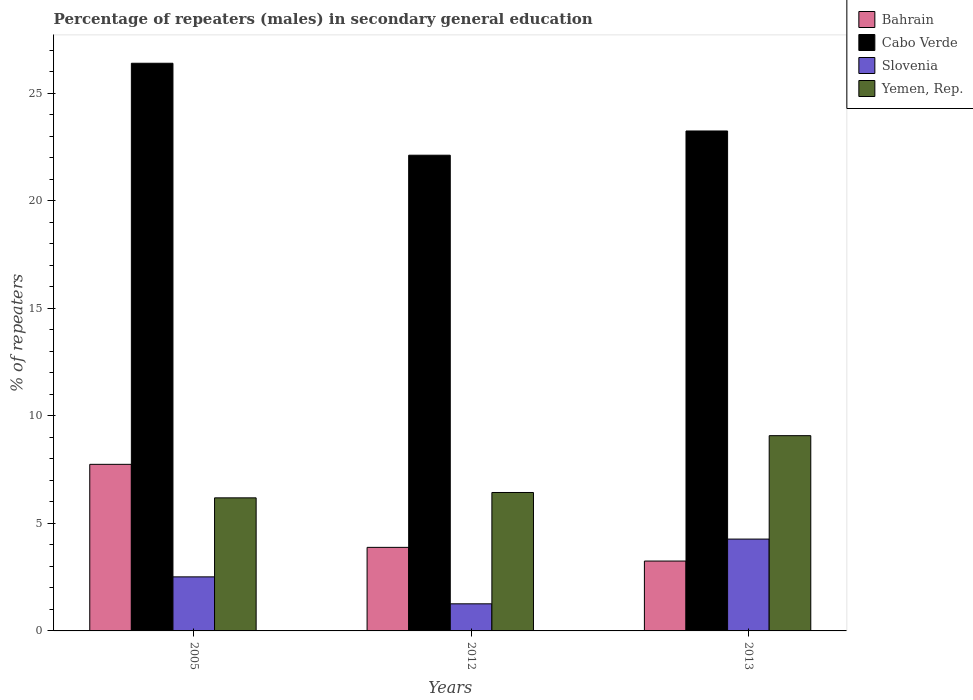How many different coloured bars are there?
Offer a very short reply. 4. How many groups of bars are there?
Your answer should be compact. 3. Are the number of bars on each tick of the X-axis equal?
Ensure brevity in your answer.  Yes. How many bars are there on the 2nd tick from the left?
Give a very brief answer. 4. How many bars are there on the 2nd tick from the right?
Your answer should be very brief. 4. What is the label of the 3rd group of bars from the left?
Ensure brevity in your answer.  2013. What is the percentage of male repeaters in Bahrain in 2005?
Provide a short and direct response. 7.74. Across all years, what is the maximum percentage of male repeaters in Bahrain?
Make the answer very short. 7.74. Across all years, what is the minimum percentage of male repeaters in Bahrain?
Your answer should be compact. 3.25. In which year was the percentage of male repeaters in Bahrain minimum?
Offer a very short reply. 2013. What is the total percentage of male repeaters in Yemen, Rep. in the graph?
Ensure brevity in your answer.  21.7. What is the difference between the percentage of male repeaters in Cabo Verde in 2012 and that in 2013?
Provide a succinct answer. -1.13. What is the difference between the percentage of male repeaters in Cabo Verde in 2005 and the percentage of male repeaters in Bahrain in 2013?
Keep it short and to the point. 23.14. What is the average percentage of male repeaters in Bahrain per year?
Your response must be concise. 4.96. In the year 2012, what is the difference between the percentage of male repeaters in Bahrain and percentage of male repeaters in Yemen, Rep.?
Provide a short and direct response. -2.55. What is the ratio of the percentage of male repeaters in Slovenia in 2005 to that in 2013?
Your answer should be compact. 0.59. What is the difference between the highest and the second highest percentage of male repeaters in Cabo Verde?
Your answer should be very brief. 3.15. What is the difference between the highest and the lowest percentage of male repeaters in Slovenia?
Ensure brevity in your answer.  3.01. Is it the case that in every year, the sum of the percentage of male repeaters in Bahrain and percentage of male repeaters in Yemen, Rep. is greater than the sum of percentage of male repeaters in Slovenia and percentage of male repeaters in Cabo Verde?
Provide a short and direct response. No. What does the 2nd bar from the left in 2012 represents?
Ensure brevity in your answer.  Cabo Verde. What does the 4th bar from the right in 2005 represents?
Give a very brief answer. Bahrain. Is it the case that in every year, the sum of the percentage of male repeaters in Yemen, Rep. and percentage of male repeaters in Bahrain is greater than the percentage of male repeaters in Cabo Verde?
Ensure brevity in your answer.  No. How many bars are there?
Ensure brevity in your answer.  12. How many years are there in the graph?
Keep it short and to the point. 3. Are the values on the major ticks of Y-axis written in scientific E-notation?
Provide a short and direct response. No. Does the graph contain any zero values?
Make the answer very short. No. Does the graph contain grids?
Ensure brevity in your answer.  No. Where does the legend appear in the graph?
Your answer should be very brief. Top right. What is the title of the graph?
Keep it short and to the point. Percentage of repeaters (males) in secondary general education. What is the label or title of the X-axis?
Provide a short and direct response. Years. What is the label or title of the Y-axis?
Ensure brevity in your answer.  % of repeaters. What is the % of repeaters of Bahrain in 2005?
Your response must be concise. 7.74. What is the % of repeaters of Cabo Verde in 2005?
Your response must be concise. 26.39. What is the % of repeaters in Slovenia in 2005?
Make the answer very short. 2.51. What is the % of repeaters in Yemen, Rep. in 2005?
Offer a very short reply. 6.19. What is the % of repeaters in Bahrain in 2012?
Make the answer very short. 3.88. What is the % of repeaters of Cabo Verde in 2012?
Your answer should be very brief. 22.11. What is the % of repeaters in Slovenia in 2012?
Make the answer very short. 1.26. What is the % of repeaters in Yemen, Rep. in 2012?
Keep it short and to the point. 6.43. What is the % of repeaters in Bahrain in 2013?
Provide a short and direct response. 3.25. What is the % of repeaters in Cabo Verde in 2013?
Give a very brief answer. 23.24. What is the % of repeaters in Slovenia in 2013?
Your response must be concise. 4.27. What is the % of repeaters of Yemen, Rep. in 2013?
Your response must be concise. 9.08. Across all years, what is the maximum % of repeaters in Bahrain?
Make the answer very short. 7.74. Across all years, what is the maximum % of repeaters in Cabo Verde?
Provide a succinct answer. 26.39. Across all years, what is the maximum % of repeaters of Slovenia?
Your answer should be compact. 4.27. Across all years, what is the maximum % of repeaters of Yemen, Rep.?
Your response must be concise. 9.08. Across all years, what is the minimum % of repeaters in Bahrain?
Make the answer very short. 3.25. Across all years, what is the minimum % of repeaters in Cabo Verde?
Your answer should be very brief. 22.11. Across all years, what is the minimum % of repeaters in Slovenia?
Your answer should be compact. 1.26. Across all years, what is the minimum % of repeaters of Yemen, Rep.?
Offer a terse response. 6.19. What is the total % of repeaters of Bahrain in the graph?
Make the answer very short. 14.87. What is the total % of repeaters of Cabo Verde in the graph?
Your response must be concise. 71.74. What is the total % of repeaters in Slovenia in the graph?
Offer a terse response. 8.04. What is the total % of repeaters of Yemen, Rep. in the graph?
Provide a short and direct response. 21.7. What is the difference between the % of repeaters of Bahrain in 2005 and that in 2012?
Offer a terse response. 3.86. What is the difference between the % of repeaters of Cabo Verde in 2005 and that in 2012?
Offer a terse response. 4.27. What is the difference between the % of repeaters of Slovenia in 2005 and that in 2012?
Provide a short and direct response. 1.25. What is the difference between the % of repeaters in Yemen, Rep. in 2005 and that in 2012?
Your answer should be compact. -0.25. What is the difference between the % of repeaters in Bahrain in 2005 and that in 2013?
Provide a short and direct response. 4.5. What is the difference between the % of repeaters in Cabo Verde in 2005 and that in 2013?
Give a very brief answer. 3.15. What is the difference between the % of repeaters of Slovenia in 2005 and that in 2013?
Keep it short and to the point. -1.76. What is the difference between the % of repeaters in Yemen, Rep. in 2005 and that in 2013?
Ensure brevity in your answer.  -2.89. What is the difference between the % of repeaters of Bahrain in 2012 and that in 2013?
Provide a succinct answer. 0.64. What is the difference between the % of repeaters in Cabo Verde in 2012 and that in 2013?
Your answer should be compact. -1.13. What is the difference between the % of repeaters of Slovenia in 2012 and that in 2013?
Your answer should be compact. -3.01. What is the difference between the % of repeaters of Yemen, Rep. in 2012 and that in 2013?
Give a very brief answer. -2.64. What is the difference between the % of repeaters of Bahrain in 2005 and the % of repeaters of Cabo Verde in 2012?
Make the answer very short. -14.37. What is the difference between the % of repeaters in Bahrain in 2005 and the % of repeaters in Slovenia in 2012?
Keep it short and to the point. 6.48. What is the difference between the % of repeaters in Bahrain in 2005 and the % of repeaters in Yemen, Rep. in 2012?
Offer a terse response. 1.31. What is the difference between the % of repeaters of Cabo Verde in 2005 and the % of repeaters of Slovenia in 2012?
Your response must be concise. 25.13. What is the difference between the % of repeaters of Cabo Verde in 2005 and the % of repeaters of Yemen, Rep. in 2012?
Make the answer very short. 19.95. What is the difference between the % of repeaters of Slovenia in 2005 and the % of repeaters of Yemen, Rep. in 2012?
Provide a succinct answer. -3.92. What is the difference between the % of repeaters of Bahrain in 2005 and the % of repeaters of Cabo Verde in 2013?
Offer a terse response. -15.49. What is the difference between the % of repeaters of Bahrain in 2005 and the % of repeaters of Slovenia in 2013?
Provide a succinct answer. 3.47. What is the difference between the % of repeaters in Bahrain in 2005 and the % of repeaters in Yemen, Rep. in 2013?
Give a very brief answer. -1.33. What is the difference between the % of repeaters of Cabo Verde in 2005 and the % of repeaters of Slovenia in 2013?
Provide a short and direct response. 22.12. What is the difference between the % of repeaters in Cabo Verde in 2005 and the % of repeaters in Yemen, Rep. in 2013?
Offer a very short reply. 17.31. What is the difference between the % of repeaters of Slovenia in 2005 and the % of repeaters of Yemen, Rep. in 2013?
Offer a terse response. -6.56. What is the difference between the % of repeaters in Bahrain in 2012 and the % of repeaters in Cabo Verde in 2013?
Ensure brevity in your answer.  -19.35. What is the difference between the % of repeaters in Bahrain in 2012 and the % of repeaters in Slovenia in 2013?
Provide a short and direct response. -0.39. What is the difference between the % of repeaters of Bahrain in 2012 and the % of repeaters of Yemen, Rep. in 2013?
Your response must be concise. -5.19. What is the difference between the % of repeaters of Cabo Verde in 2012 and the % of repeaters of Slovenia in 2013?
Ensure brevity in your answer.  17.84. What is the difference between the % of repeaters in Cabo Verde in 2012 and the % of repeaters in Yemen, Rep. in 2013?
Make the answer very short. 13.04. What is the difference between the % of repeaters of Slovenia in 2012 and the % of repeaters of Yemen, Rep. in 2013?
Provide a succinct answer. -7.82. What is the average % of repeaters of Bahrain per year?
Offer a very short reply. 4.96. What is the average % of repeaters in Cabo Verde per year?
Offer a very short reply. 23.91. What is the average % of repeaters in Slovenia per year?
Your answer should be compact. 2.68. What is the average % of repeaters in Yemen, Rep. per year?
Give a very brief answer. 7.23. In the year 2005, what is the difference between the % of repeaters of Bahrain and % of repeaters of Cabo Verde?
Give a very brief answer. -18.64. In the year 2005, what is the difference between the % of repeaters of Bahrain and % of repeaters of Slovenia?
Your response must be concise. 5.23. In the year 2005, what is the difference between the % of repeaters of Bahrain and % of repeaters of Yemen, Rep.?
Ensure brevity in your answer.  1.56. In the year 2005, what is the difference between the % of repeaters of Cabo Verde and % of repeaters of Slovenia?
Ensure brevity in your answer.  23.87. In the year 2005, what is the difference between the % of repeaters of Cabo Verde and % of repeaters of Yemen, Rep.?
Provide a succinct answer. 20.2. In the year 2005, what is the difference between the % of repeaters in Slovenia and % of repeaters in Yemen, Rep.?
Offer a very short reply. -3.67. In the year 2012, what is the difference between the % of repeaters in Bahrain and % of repeaters in Cabo Verde?
Give a very brief answer. -18.23. In the year 2012, what is the difference between the % of repeaters of Bahrain and % of repeaters of Slovenia?
Your answer should be compact. 2.62. In the year 2012, what is the difference between the % of repeaters in Bahrain and % of repeaters in Yemen, Rep.?
Offer a very short reply. -2.55. In the year 2012, what is the difference between the % of repeaters in Cabo Verde and % of repeaters in Slovenia?
Provide a succinct answer. 20.85. In the year 2012, what is the difference between the % of repeaters in Cabo Verde and % of repeaters in Yemen, Rep.?
Ensure brevity in your answer.  15.68. In the year 2012, what is the difference between the % of repeaters of Slovenia and % of repeaters of Yemen, Rep.?
Offer a very short reply. -5.17. In the year 2013, what is the difference between the % of repeaters in Bahrain and % of repeaters in Cabo Verde?
Your answer should be compact. -19.99. In the year 2013, what is the difference between the % of repeaters of Bahrain and % of repeaters of Slovenia?
Make the answer very short. -1.02. In the year 2013, what is the difference between the % of repeaters in Bahrain and % of repeaters in Yemen, Rep.?
Your answer should be compact. -5.83. In the year 2013, what is the difference between the % of repeaters of Cabo Verde and % of repeaters of Slovenia?
Provide a short and direct response. 18.97. In the year 2013, what is the difference between the % of repeaters of Cabo Verde and % of repeaters of Yemen, Rep.?
Provide a short and direct response. 14.16. In the year 2013, what is the difference between the % of repeaters in Slovenia and % of repeaters in Yemen, Rep.?
Provide a succinct answer. -4.81. What is the ratio of the % of repeaters in Bahrain in 2005 to that in 2012?
Your answer should be very brief. 1.99. What is the ratio of the % of repeaters in Cabo Verde in 2005 to that in 2012?
Your response must be concise. 1.19. What is the ratio of the % of repeaters of Slovenia in 2005 to that in 2012?
Give a very brief answer. 1.99. What is the ratio of the % of repeaters of Yemen, Rep. in 2005 to that in 2012?
Your answer should be very brief. 0.96. What is the ratio of the % of repeaters of Bahrain in 2005 to that in 2013?
Your answer should be compact. 2.38. What is the ratio of the % of repeaters in Cabo Verde in 2005 to that in 2013?
Make the answer very short. 1.14. What is the ratio of the % of repeaters in Slovenia in 2005 to that in 2013?
Your answer should be compact. 0.59. What is the ratio of the % of repeaters of Yemen, Rep. in 2005 to that in 2013?
Offer a very short reply. 0.68. What is the ratio of the % of repeaters in Bahrain in 2012 to that in 2013?
Your answer should be very brief. 1.2. What is the ratio of the % of repeaters of Cabo Verde in 2012 to that in 2013?
Offer a terse response. 0.95. What is the ratio of the % of repeaters in Slovenia in 2012 to that in 2013?
Your answer should be very brief. 0.3. What is the ratio of the % of repeaters of Yemen, Rep. in 2012 to that in 2013?
Provide a short and direct response. 0.71. What is the difference between the highest and the second highest % of repeaters of Bahrain?
Give a very brief answer. 3.86. What is the difference between the highest and the second highest % of repeaters of Cabo Verde?
Provide a succinct answer. 3.15. What is the difference between the highest and the second highest % of repeaters of Slovenia?
Your answer should be compact. 1.76. What is the difference between the highest and the second highest % of repeaters in Yemen, Rep.?
Keep it short and to the point. 2.64. What is the difference between the highest and the lowest % of repeaters in Bahrain?
Provide a short and direct response. 4.5. What is the difference between the highest and the lowest % of repeaters in Cabo Verde?
Provide a short and direct response. 4.27. What is the difference between the highest and the lowest % of repeaters in Slovenia?
Your response must be concise. 3.01. What is the difference between the highest and the lowest % of repeaters in Yemen, Rep.?
Ensure brevity in your answer.  2.89. 